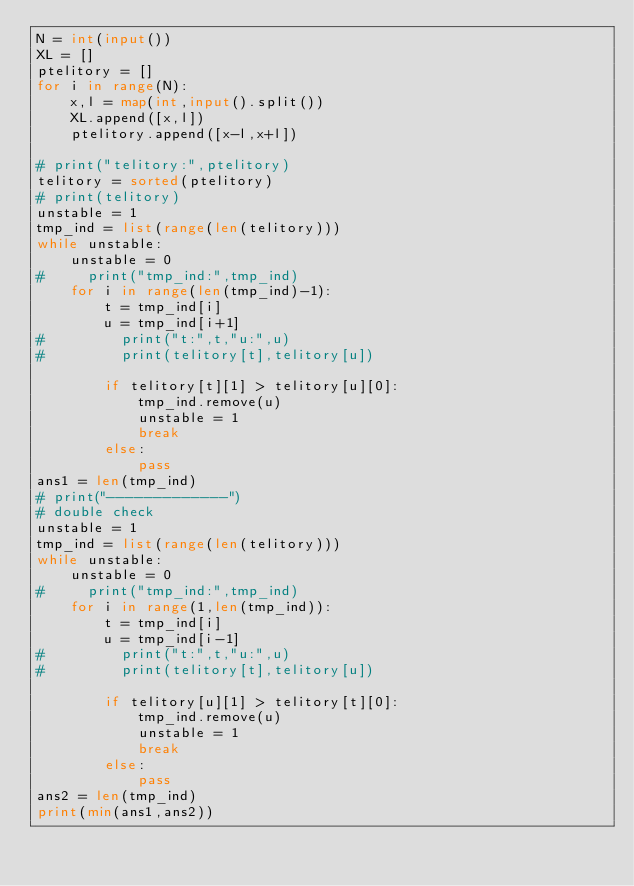Convert code to text. <code><loc_0><loc_0><loc_500><loc_500><_Python_>N = int(input())
XL = []
ptelitory = []
for i in range(N):
    x,l = map(int,input().split())
    XL.append([x,l])
    ptelitory.append([x-l,x+l])

# print("telitory:",ptelitory)
telitory = sorted(ptelitory)
# print(telitory)
unstable = 1
tmp_ind = list(range(len(telitory)))
while unstable:
    unstable = 0
#     print("tmp_ind:",tmp_ind)
    for i in range(len(tmp_ind)-1):
        t = tmp_ind[i]
        u = tmp_ind[i+1]
#         print("t:",t,"u:",u)
#         print(telitory[t],telitory[u])

        if telitory[t][1] > telitory[u][0]: 
            tmp_ind.remove(u)
            unstable = 1
            break
        else:
            pass
ans1 = len(tmp_ind)   
# print("-------------")
# double check
unstable = 1
tmp_ind = list(range(len(telitory)))
while unstable:
    unstable = 0
#     print("tmp_ind:",tmp_ind)
    for i in range(1,len(tmp_ind)):
        t = tmp_ind[i]
        u = tmp_ind[i-1]
#         print("t:",t,"u:",u)
#         print(telitory[t],telitory[u])

        if telitory[u][1] > telitory[t][0]: 
            tmp_ind.remove(u)
            unstable = 1
            break
        else:
            pass
ans2 = len(tmp_ind)
print(min(ans1,ans2))</code> 